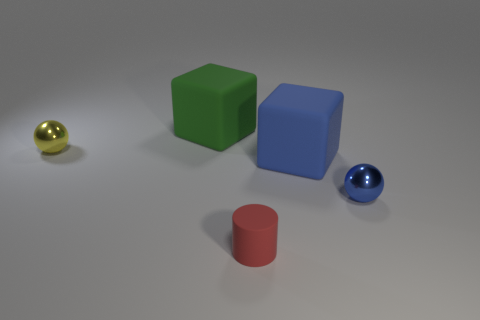Add 3 green shiny cylinders. How many objects exist? 8 Subtract all cubes. How many objects are left? 3 Add 5 yellow metallic objects. How many yellow metallic objects exist? 6 Subtract 0 blue cylinders. How many objects are left? 5 Subtract all tiny cyan metallic balls. Subtract all tiny red rubber cylinders. How many objects are left? 4 Add 4 big green rubber things. How many big green rubber things are left? 5 